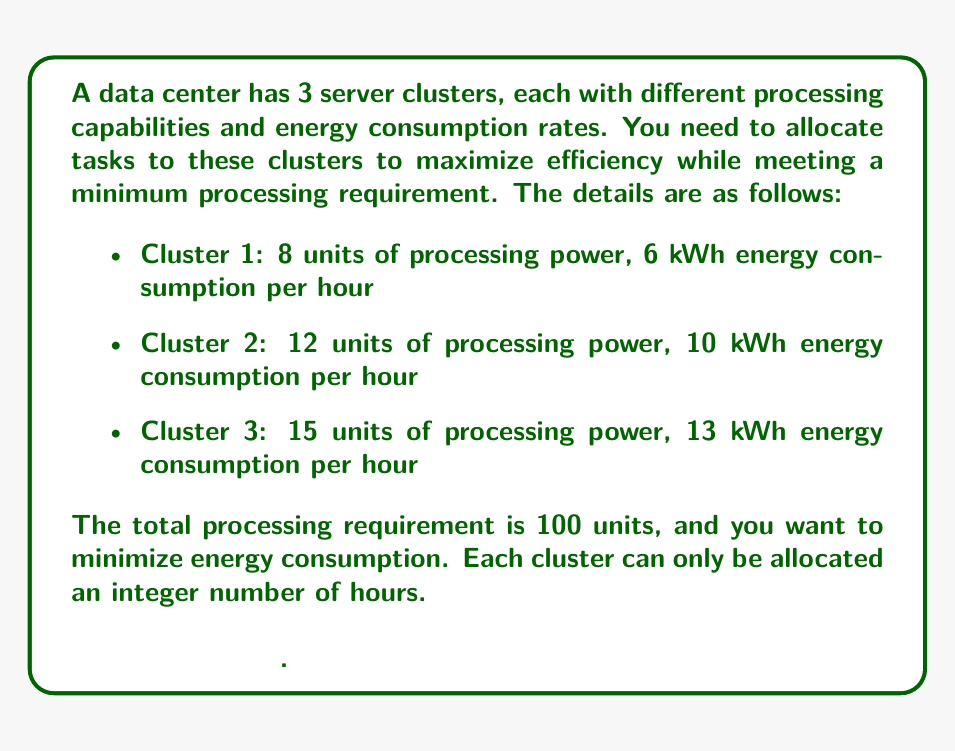Solve this math problem. To formalize this as an integer programming problem, we need to define our variables, objective function, and constraints.

Let $x_1$, $x_2$, and $x_3$ be the number of hours allocated to Clusters 1, 2, and 3 respectively.

Objective function (minimize energy consumption):
$$\text{Minimize } Z = 6x_1 + 10x_2 + 13x_3$$

Constraints:
1. Meet processing requirement:
   $$8x_1 + 12x_2 + 15x_3 \geq 100$$

2. Non-negativity and integer constraints:
   $$x_1, x_2, x_3 \geq 0 \text{ and integer}$$

To solve this problem, we can use the branch and bound method or a solver like CPLEX or Gurobi. However, for this relatively simple problem, we can also use a systematic approach:

1. Start by allocating time to the most efficient cluster (Cluster 1) until we reach its capacity or meet the requirement.
2. If the requirement is not met, move to the next most efficient cluster (Cluster 2), and so on.

Cluster 1: 8 units/hour, 6 kWh/hour
Efficiency: 8/6 = 1.33 units/kWh

Cluster 2: 12 units/hour, 10 kWh/hour
Efficiency: 12/10 = 1.2 units/kWh

Cluster 3: 15 units/hour, 13 kWh/hour
Efficiency: 15/13 ≈ 1.15 units/kWh

Starting with Cluster 1:
12 hours * 8 units/hour = 96 units
Remaining: 4 units

For the remaining 4 units, we need to use Cluster 2 for 1 hour:
1 hour * 12 units/hour = 12 units (which exceeds our remaining need, but it's the minimum we can allocate)

Therefore, the optimal allocation is:
x₁ = 12 hours (Cluster 1)
x₂ = 1 hour (Cluster 2)
x₃ = 0 hours (Cluster 3)

Total energy consumption: 12 * 6 + 1 * 10 = 82 kWh
Total processing: 12 * 8 + 1 * 12 = 108 units (which satisfies our ≥ 100 constraint)
Answer: Оптимальное распределение:
$$x_1 = 12, x_2 = 1, x_3 = 0$$
Минимальное энергопотребление: 82 кВт·ч 